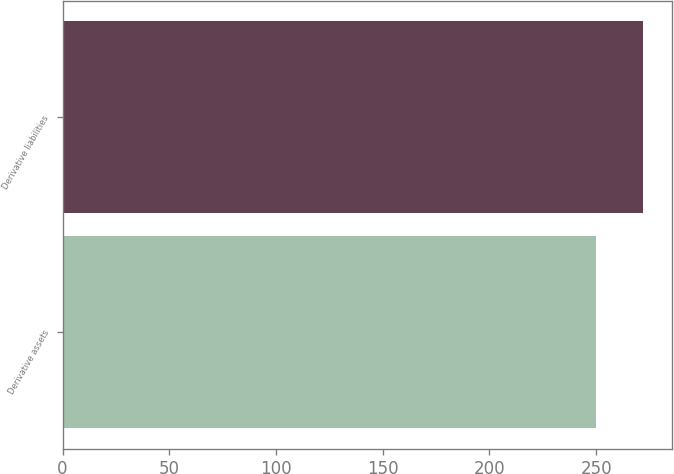Convert chart. <chart><loc_0><loc_0><loc_500><loc_500><bar_chart><fcel>Derivative assets<fcel>Derivative liabilities<nl><fcel>250<fcel>272<nl></chart> 